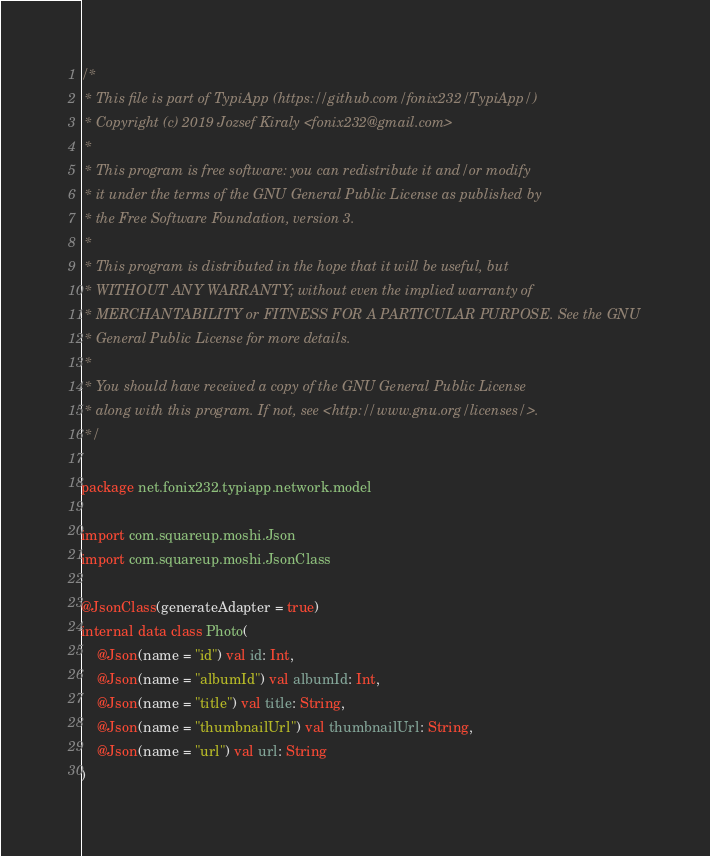Convert code to text. <code><loc_0><loc_0><loc_500><loc_500><_Kotlin_>/*
 * This file is part of TypiApp (https://github.com/fonix232/TypiApp/)
 * Copyright (c) 2019 Jozsef Kiraly <fonix232@gmail.com>
 *
 * This program is free software: you can redistribute it and/or modify
 * it under the terms of the GNU General Public License as published by
 * the Free Software Foundation, version 3.
 *
 * This program is distributed in the hope that it will be useful, but
 * WITHOUT ANY WARRANTY; without even the implied warranty of
 * MERCHANTABILITY or FITNESS FOR A PARTICULAR PURPOSE. See the GNU
 * General Public License for more details.
 *
 * You should have received a copy of the GNU General Public License
 * along with this program. If not, see <http://www.gnu.org/licenses/>.
 */

package net.fonix232.typiapp.network.model

import com.squareup.moshi.Json
import com.squareup.moshi.JsonClass

@JsonClass(generateAdapter = true)
internal data class Photo(
    @Json(name = "id") val id: Int,
    @Json(name = "albumId") val albumId: Int,
    @Json(name = "title") val title: String,
    @Json(name = "thumbnailUrl") val thumbnailUrl: String,
    @Json(name = "url") val url: String
)
</code> 